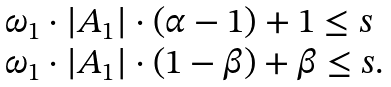Convert formula to latex. <formula><loc_0><loc_0><loc_500><loc_500>\begin{array} { l } \omega _ { 1 } \cdot | A _ { 1 } | \cdot ( \alpha - 1 ) + 1 \leq s \\ \omega _ { 1 } \cdot | A _ { 1 } | \cdot ( 1 - \beta ) + \beta \leq s . \\ \end{array}</formula> 